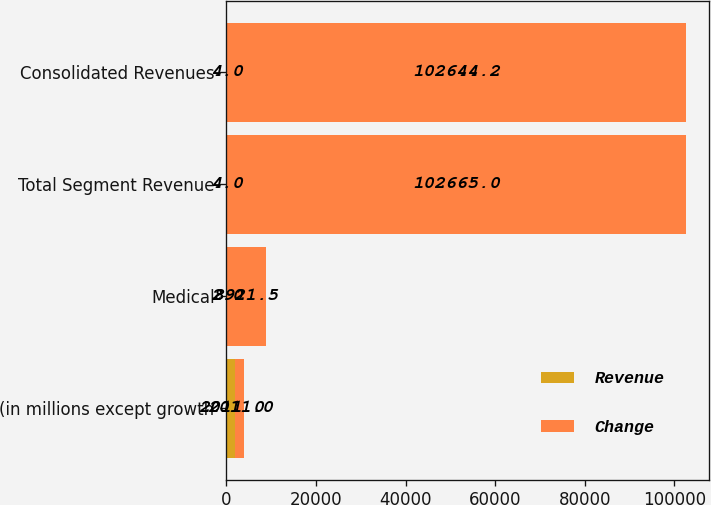Convert chart to OTSL. <chart><loc_0><loc_0><loc_500><loc_500><stacked_bar_chart><ecel><fcel>(in millions except growth<fcel>Medical<fcel>Total Segment Revenue<fcel>Consolidated Revenues<nl><fcel>Revenue<fcel>2011<fcel>2<fcel>4<fcel>4<nl><fcel>Change<fcel>2011<fcel>8921.5<fcel>102665<fcel>102644<nl></chart> 